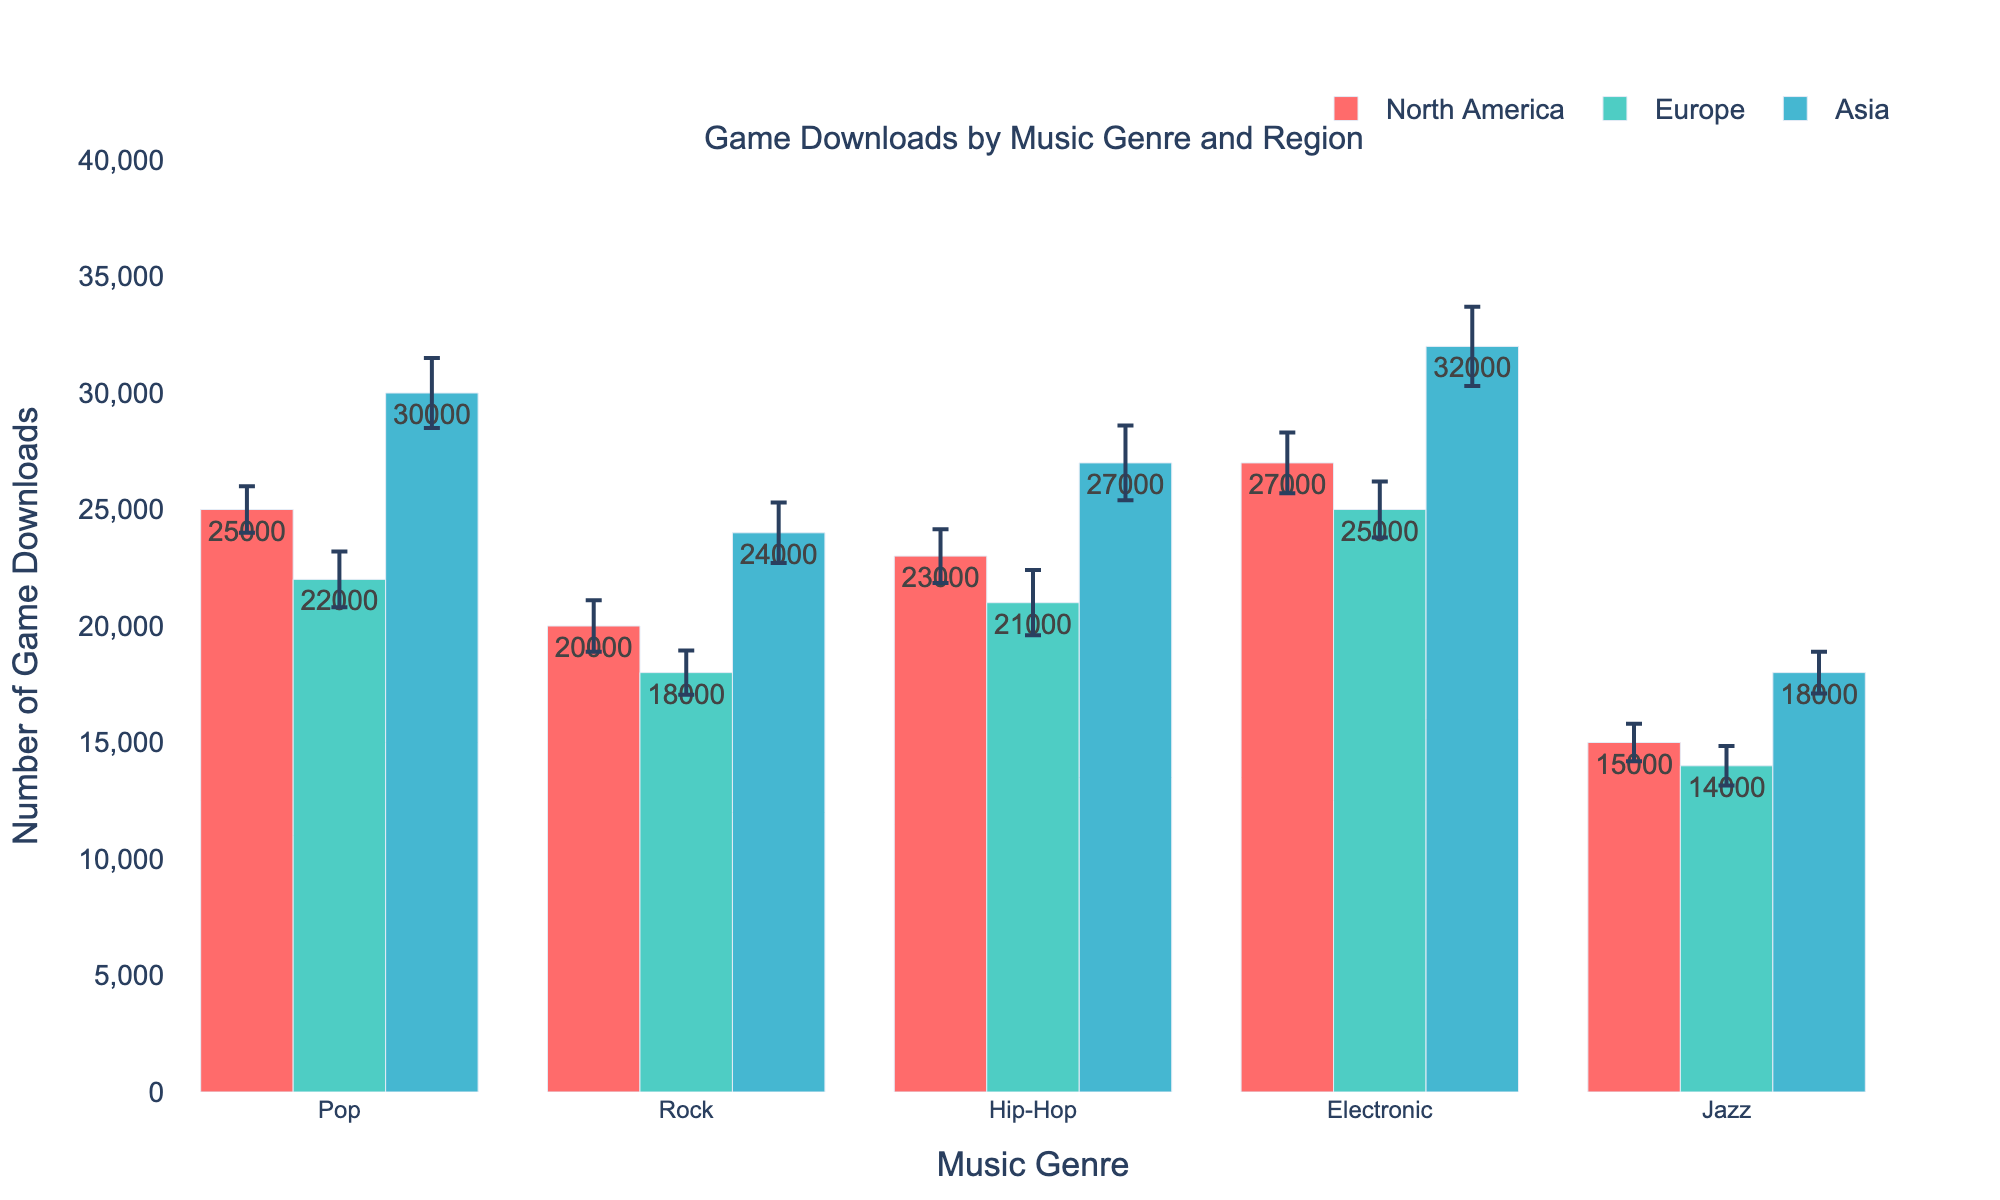What's the title of the figure? The title is typically displayed at the top of the figure and provides a summary of what the figure is about.
Answer: Game Downloads by Music Genre and Region What's the average number of downloads for Jazz across all regions? Sum the mean downloads for Jazz in North America, Europe, and Asia, then divide by the number of regions. (15000 + 14000 + 18000) / 3 = 47000 / 3
Answer: 15667 Which music genre shows the highest variability in downloads across regions? The genre with the largest standard error values across regions will have the highest variability. For each genre, compare the sum of the standard errors across regions.
Answer: Hip-Hop Between Rock and Electronic, which genre had more downloads in Europe? Compare the mean downloads in Europe for Rock and Electronic. Rock has 18000 downloads, while Electronic has 25000 downloads. Therefore, Electronic has more.
Answer: Electronic What is the total number of game downloads for Pop music across all regions? Sum the mean downloads for Pop in North America, Europe, and Asia. 25000 + 22000 + 30000 = 77000
Answer: 77000 How does the number of game downloads for Hip-Hop in North America compare to Jazz in the same region? Compare the mean downloads for Hip-Hop and Jazz in North America. Hip-Hop has 23000 downloads, and Jazz has 15000 downloads, so Hip-Hop has more.
Answer: Hip-Hop What's the difference in downloads between the highest and lowest downloaded genres in Asia? Identify the genres with the highest (Electronic, 32000) and lowest (Jazz, 18000) downloads in Asia, then subtract the lowest from the highest. 32000 - 18000 = 14000
Answer: 14000 Which genre has the highest mean downloads in Asia? Look at the mean downloads for each genre in Asia. Electronic has the highest with 32000 downloads.
Answer: Electronic What are the error bars on the plot indicating? The error bars represent the variability or standard error in the number of downloads for each music genre across different regions. They show the uncertainty in the measured mean downloads.
Answer: Variability in downloads 